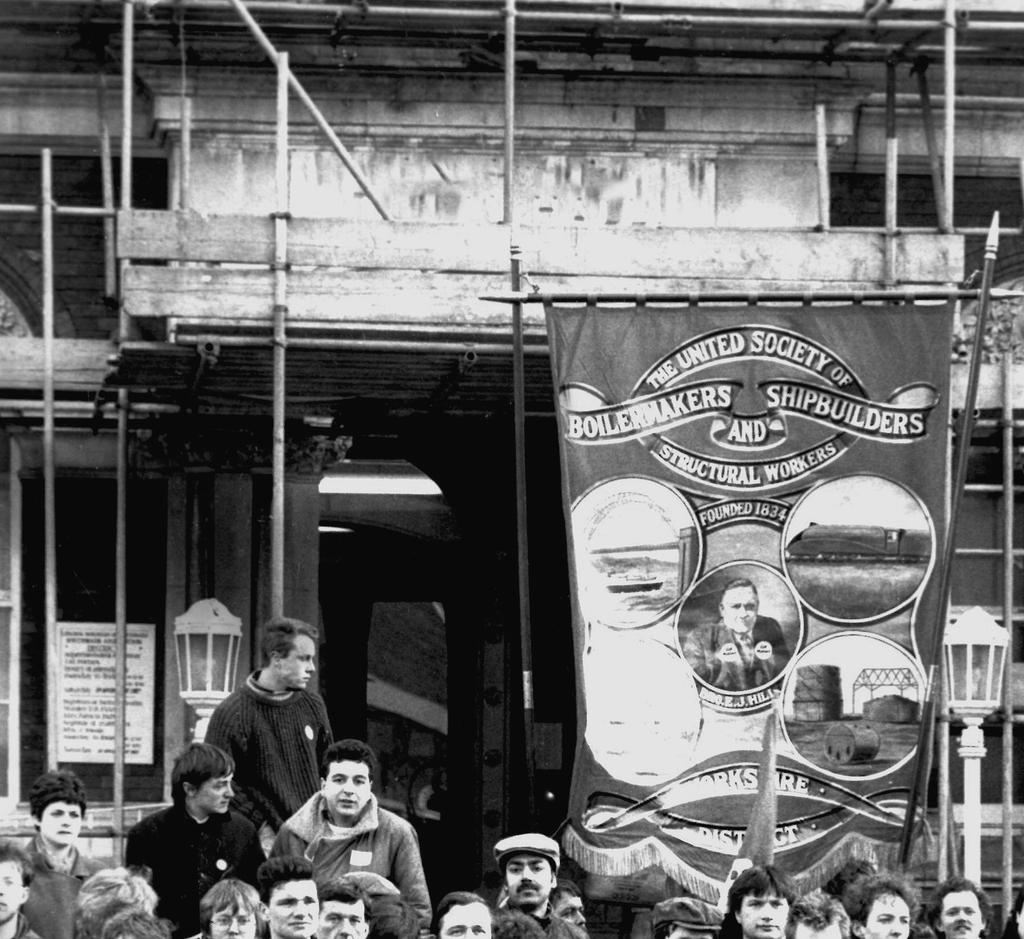What is the main structure visible in the image? There is a building in the image. Are there any people near the building? Yes, there is a group of people in front of the building. What is attached to the building? There is a banner attached to the building. What type of cream is being used to help make the decision in the image? There is no cream or decision-making process depicted in the image. 